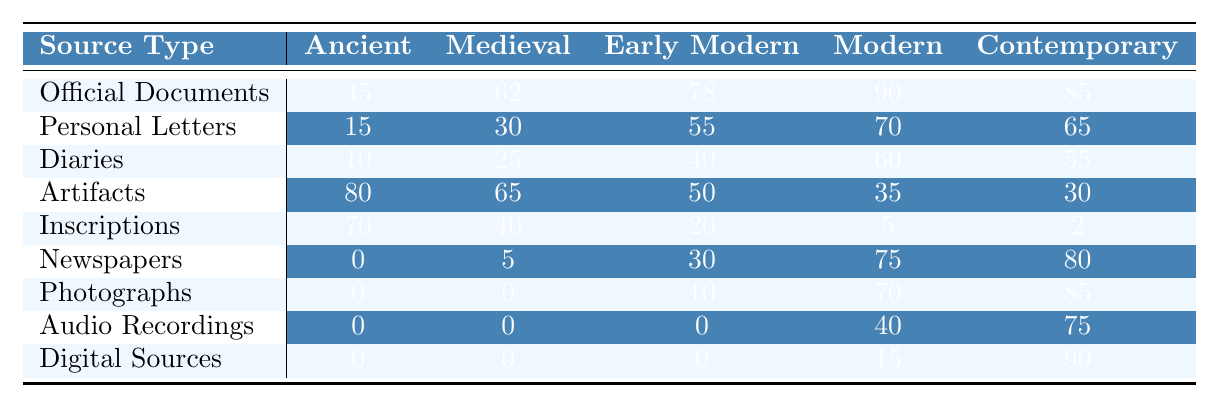What is the highest number of Official Documents recorded in a single era? The highest number of Official Documents is found in the Modern era, with a total of 90. By scanning the table, we observe the values for each era: 45 for Ancient, 62 for Medieval, 78 for Early Modern, 90 for Modern, and 85 for Contemporary. The Modern era has the highest count.
Answer: 90 Which source type has the least number recorded in the Ancient era? The source type with the least number in the Ancient era is Newspapers, which has a count of 0. By reviewing the values for the Ancient era, Newspapers show the lowest figure when compared with others listed.
Answer: 0 In which era does the number of Personal Letters first exceed 50? The number of Personal Letters first exceeds 50 in the Early Modern era, which has a count of 55. By examining the table, the values for Personal Letters in each era are 15, 30, 55, 70, and 65. The count surpasses 50 for the first time in the Early Modern era.
Answer: Early Modern What is the average number of Artifacts across all eras? To calculate the average, we first sum the number of Artifacts: 80 + 65 + 50 + 35 + 30 = 260. Then, we divide by the number of eras, which is 5. Thus, 260 ÷ 5 = 52.
Answer: 52 Is it true that the number of Digital Sources is greater in the Contemporary era than in the Early Modern era? Yes, it is true. The number of Digital Sources in the Contemporary era is 90, while in the Early Modern era, it is 0. By comparing these values directly from the table, the Contemporary era clearly has a higher count.
Answer: Yes Which era has a larger number of Photographs than Diaries combined? The Modern era has a number of Photographs (70) that exceeds the combined total of Diaries (60) in that same era. By adding the number of Diaries (60) to see if any era has more Photographs than that and checking each era, only Modern exceeds this sum in that comparison.
Answer: Modern What is the difference in the number of Inscriptions between the Ancient era and the Contemporary era? The difference is calculated by subtracting the number of Inscriptions in the Contemporary era (2) from that in the Ancient era (70). Thus, 70 - 2 = 68.
Answer: 68 How many Newspapers were used as primary sources in the Medieval era compared to the Early Modern era? The number of Newspapers in the Medieval era is 5, while in the Early Modern era it is 30. By comparing these two values directly, we find that the Early Modern era has more Newspapers.
Answer: 30 What source type experienced the least usage in both the Ancient and Medieval eras combined? When combining the Ancient (0) and Medieval (0) values for Newspapers, it results in 0, which is less than any other source type in either of the two eras. From the table's listings, we see that Newspapers had no recorded usage in those specific times.
Answer: Newspapers Which source type shows the most significant increase from the Early Modern to the Modern era? The Newspapers type shows the most significant increase, from 30 in the Early Modern era to 75 in the Modern era, which is an increase of 45. By assessing the data between those two eras, Newspapers show the highest growth.
Answer: Newspapers 